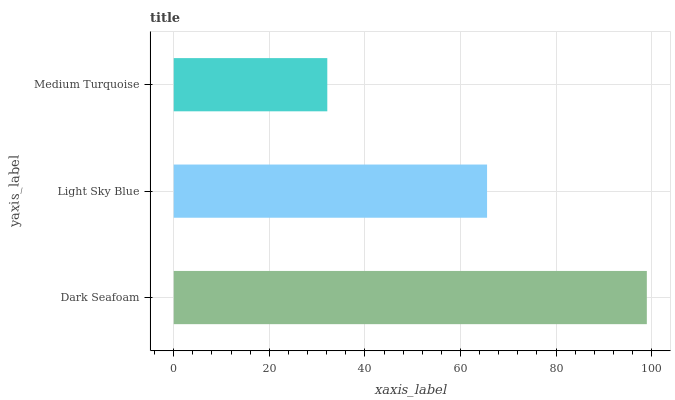Is Medium Turquoise the minimum?
Answer yes or no. Yes. Is Dark Seafoam the maximum?
Answer yes or no. Yes. Is Light Sky Blue the minimum?
Answer yes or no. No. Is Light Sky Blue the maximum?
Answer yes or no. No. Is Dark Seafoam greater than Light Sky Blue?
Answer yes or no. Yes. Is Light Sky Blue less than Dark Seafoam?
Answer yes or no. Yes. Is Light Sky Blue greater than Dark Seafoam?
Answer yes or no. No. Is Dark Seafoam less than Light Sky Blue?
Answer yes or no. No. Is Light Sky Blue the high median?
Answer yes or no. Yes. Is Light Sky Blue the low median?
Answer yes or no. Yes. Is Medium Turquoise the high median?
Answer yes or no. No. Is Medium Turquoise the low median?
Answer yes or no. No. 